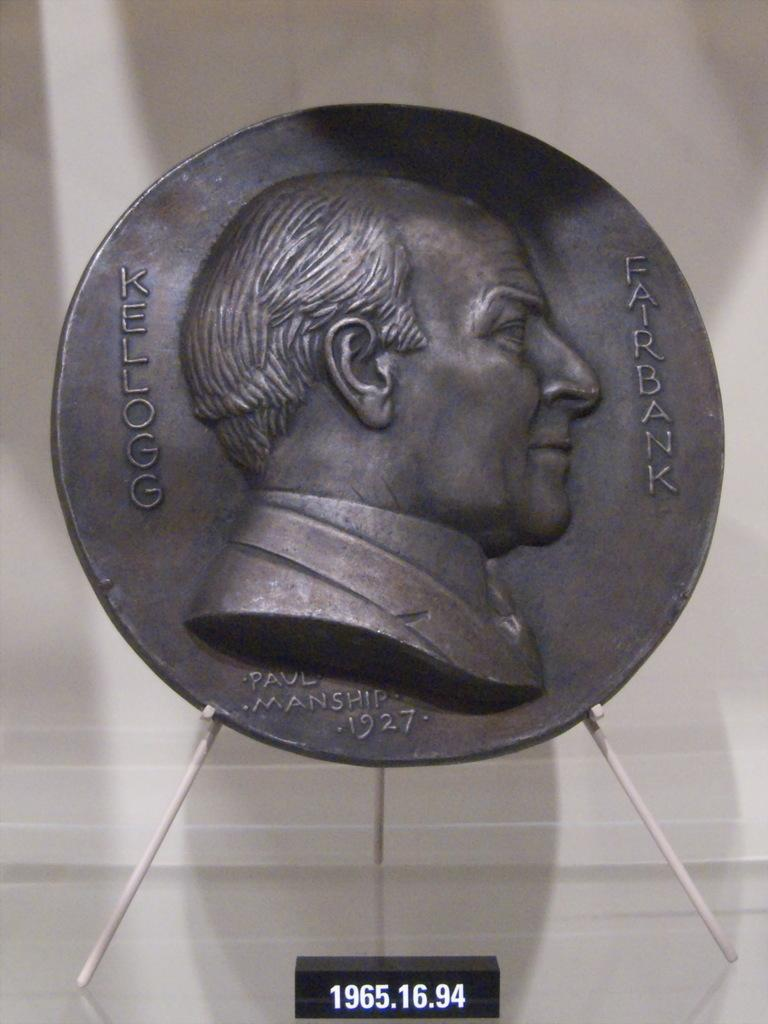<image>
Give a short and clear explanation of the subsequent image. A relief of Kellogg Fairbank is displayed on a stand. 